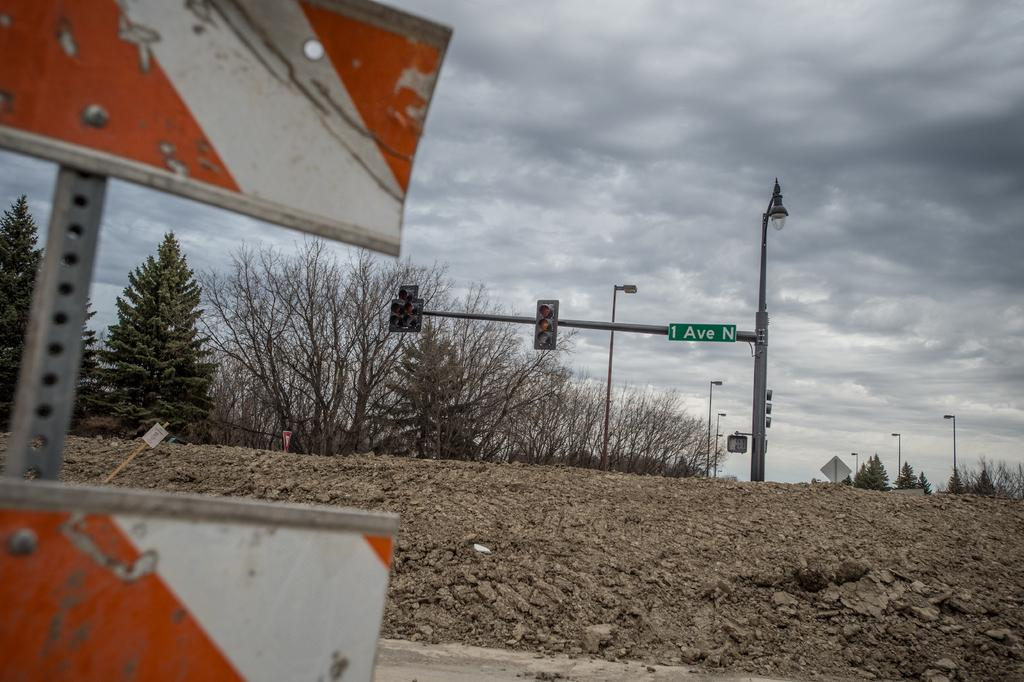<image>
Describe the image concisely. Street with a sign that leads to 1 Ave N 